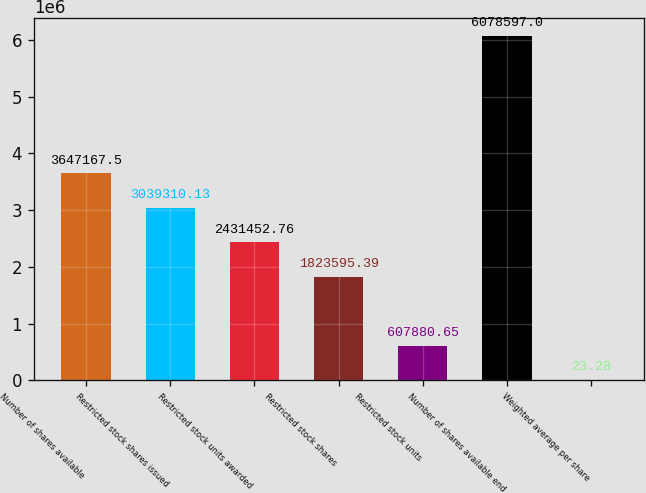Convert chart to OTSL. <chart><loc_0><loc_0><loc_500><loc_500><bar_chart><fcel>Number of shares available<fcel>Restricted stock shares issued<fcel>Restricted stock units awarded<fcel>Restricted stock shares<fcel>Restricted stock units<fcel>Number of shares available end<fcel>Weighted average per share<nl><fcel>3.64717e+06<fcel>3.03931e+06<fcel>2.43145e+06<fcel>1.8236e+06<fcel>607881<fcel>6.0786e+06<fcel>23.28<nl></chart> 